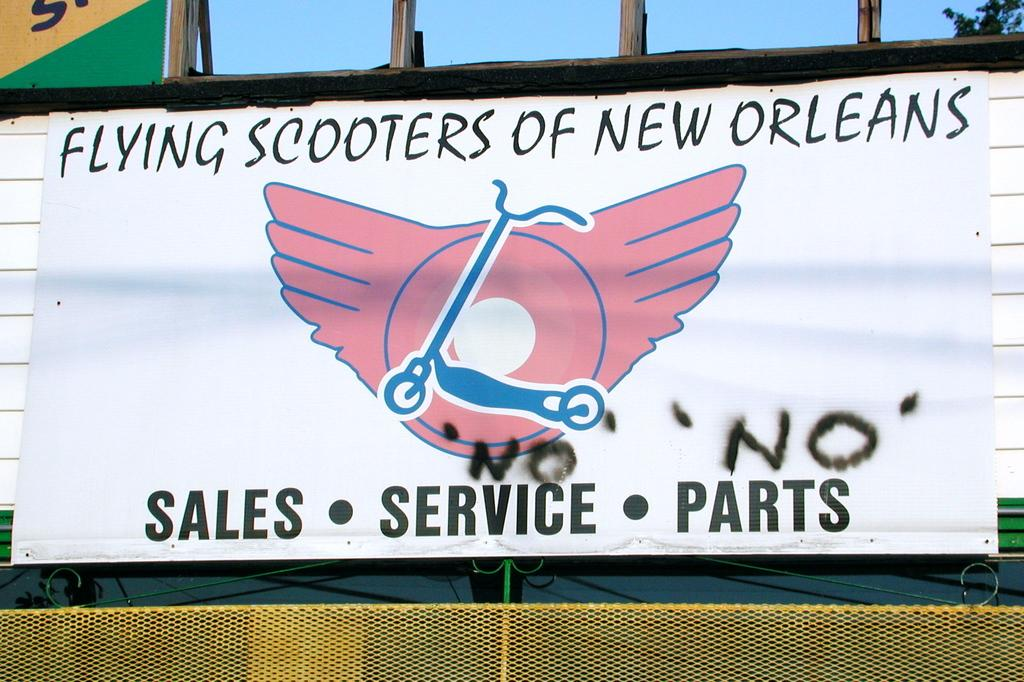<image>
Offer a succinct explanation of the picture presented. a banner with pink wings logo for flying scooters of new orleans 